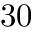Convert formula to latex. <formula><loc_0><loc_0><loc_500><loc_500>3 0</formula> 